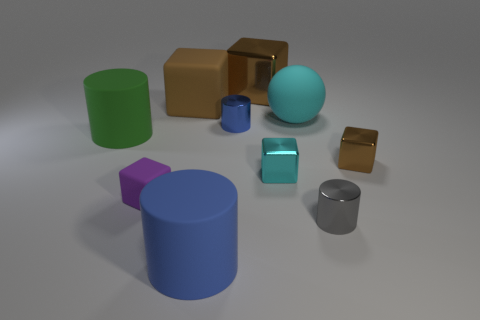What is the size of the matte thing that is the same color as the large shiny block?
Provide a succinct answer. Large. There is a tiny thing behind the brown object in front of the cyan object that is behind the small brown block; what is it made of?
Ensure brevity in your answer.  Metal. What number of objects are big blue rubber things or small red rubber cylinders?
Your answer should be very brief. 1. What is the shape of the tiny cyan object?
Make the answer very short. Cube. The large brown thing that is to the left of the tiny object behind the large green cylinder is what shape?
Give a very brief answer. Cube. Does the small cyan thing that is in front of the blue metal object have the same material as the small gray object?
Make the answer very short. Yes. What number of cyan objects are either shiny blocks or small things?
Give a very brief answer. 1. Is there a small metal block of the same color as the rubber ball?
Keep it short and to the point. Yes. Are there any tiny red cylinders made of the same material as the large cyan thing?
Make the answer very short. No. There is a tiny metallic thing that is on the left side of the big cyan matte sphere and right of the large brown metallic object; what is its shape?
Provide a short and direct response. Cube. 